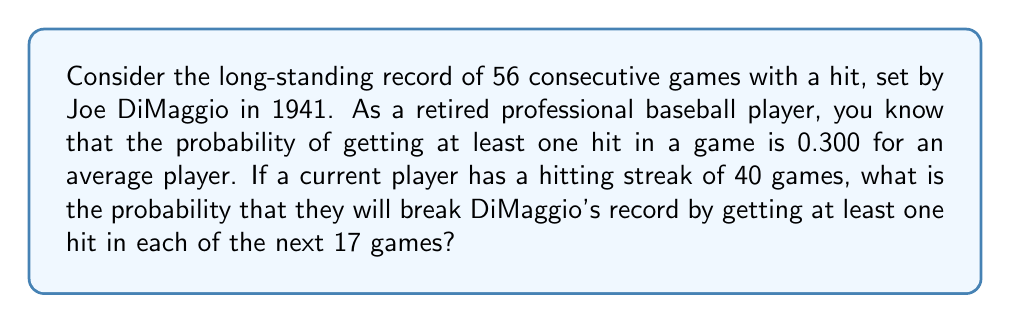Show me your answer to this math problem. Let's approach this step-by-step:

1) To break the record, the player needs to get at least one hit in each of the next 17 games.

2) The probability of getting at least one hit in a single game is 0.300.

3) We need to calculate the probability of this event occurring 17 times in a row.

4) This is a case of independent events, where the probability of success remains constant for each trial.

5) The probability of a series of independent events all occurring is the product of their individual probabilities.

6) Therefore, the probability of getting at least one hit in all 17 games is:

   $$P(\text{breaking record}) = (0.300)^{17}$$

7) Let's calculate this:

   $$P(\text{breaking record}) = (0.300)^{17} \approx 5.1726 \times 10^{-9}$$

8) To express this as odds, we can use the formula:

   $$\text{Odds} = \frac{P(\text{event})}{1 - P(\text{event})}$$

9) Substituting our probability:

   $$\text{Odds} = \frac{5.1726 \times 10^{-9}}{1 - 5.1726 \times 10^{-9}} \approx 5.1726 \times 10^{-9}$$

10) The odds are approximately 1 in 193,325,714.
Answer: Approximately 1 in 193,325,714 